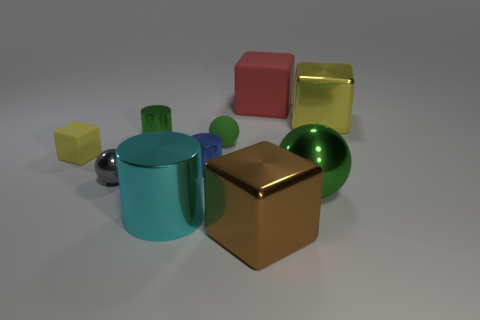Subtract 1 cubes. How many cubes are left? 3 Subtract all cubes. How many objects are left? 6 Add 8 red objects. How many red objects are left? 9 Add 5 tiny green metal cylinders. How many tiny green metal cylinders exist? 6 Subtract 0 yellow cylinders. How many objects are left? 10 Subtract all tiny red matte things. Subtract all red matte blocks. How many objects are left? 9 